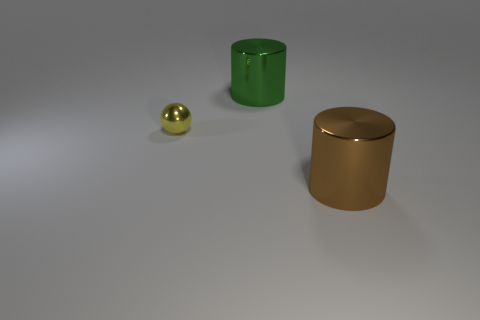Add 2 green objects. How many objects exist? 5 Subtract all green cylinders. How many cylinders are left? 1 Subtract 1 cylinders. How many cylinders are left? 1 Subtract all cyan blocks. How many green cylinders are left? 1 Subtract all small blue shiny spheres. Subtract all yellow things. How many objects are left? 2 Add 2 large brown cylinders. How many large brown cylinders are left? 3 Add 1 cylinders. How many cylinders exist? 3 Subtract 0 gray cylinders. How many objects are left? 3 Subtract all balls. How many objects are left? 2 Subtract all purple cylinders. Subtract all gray blocks. How many cylinders are left? 2 